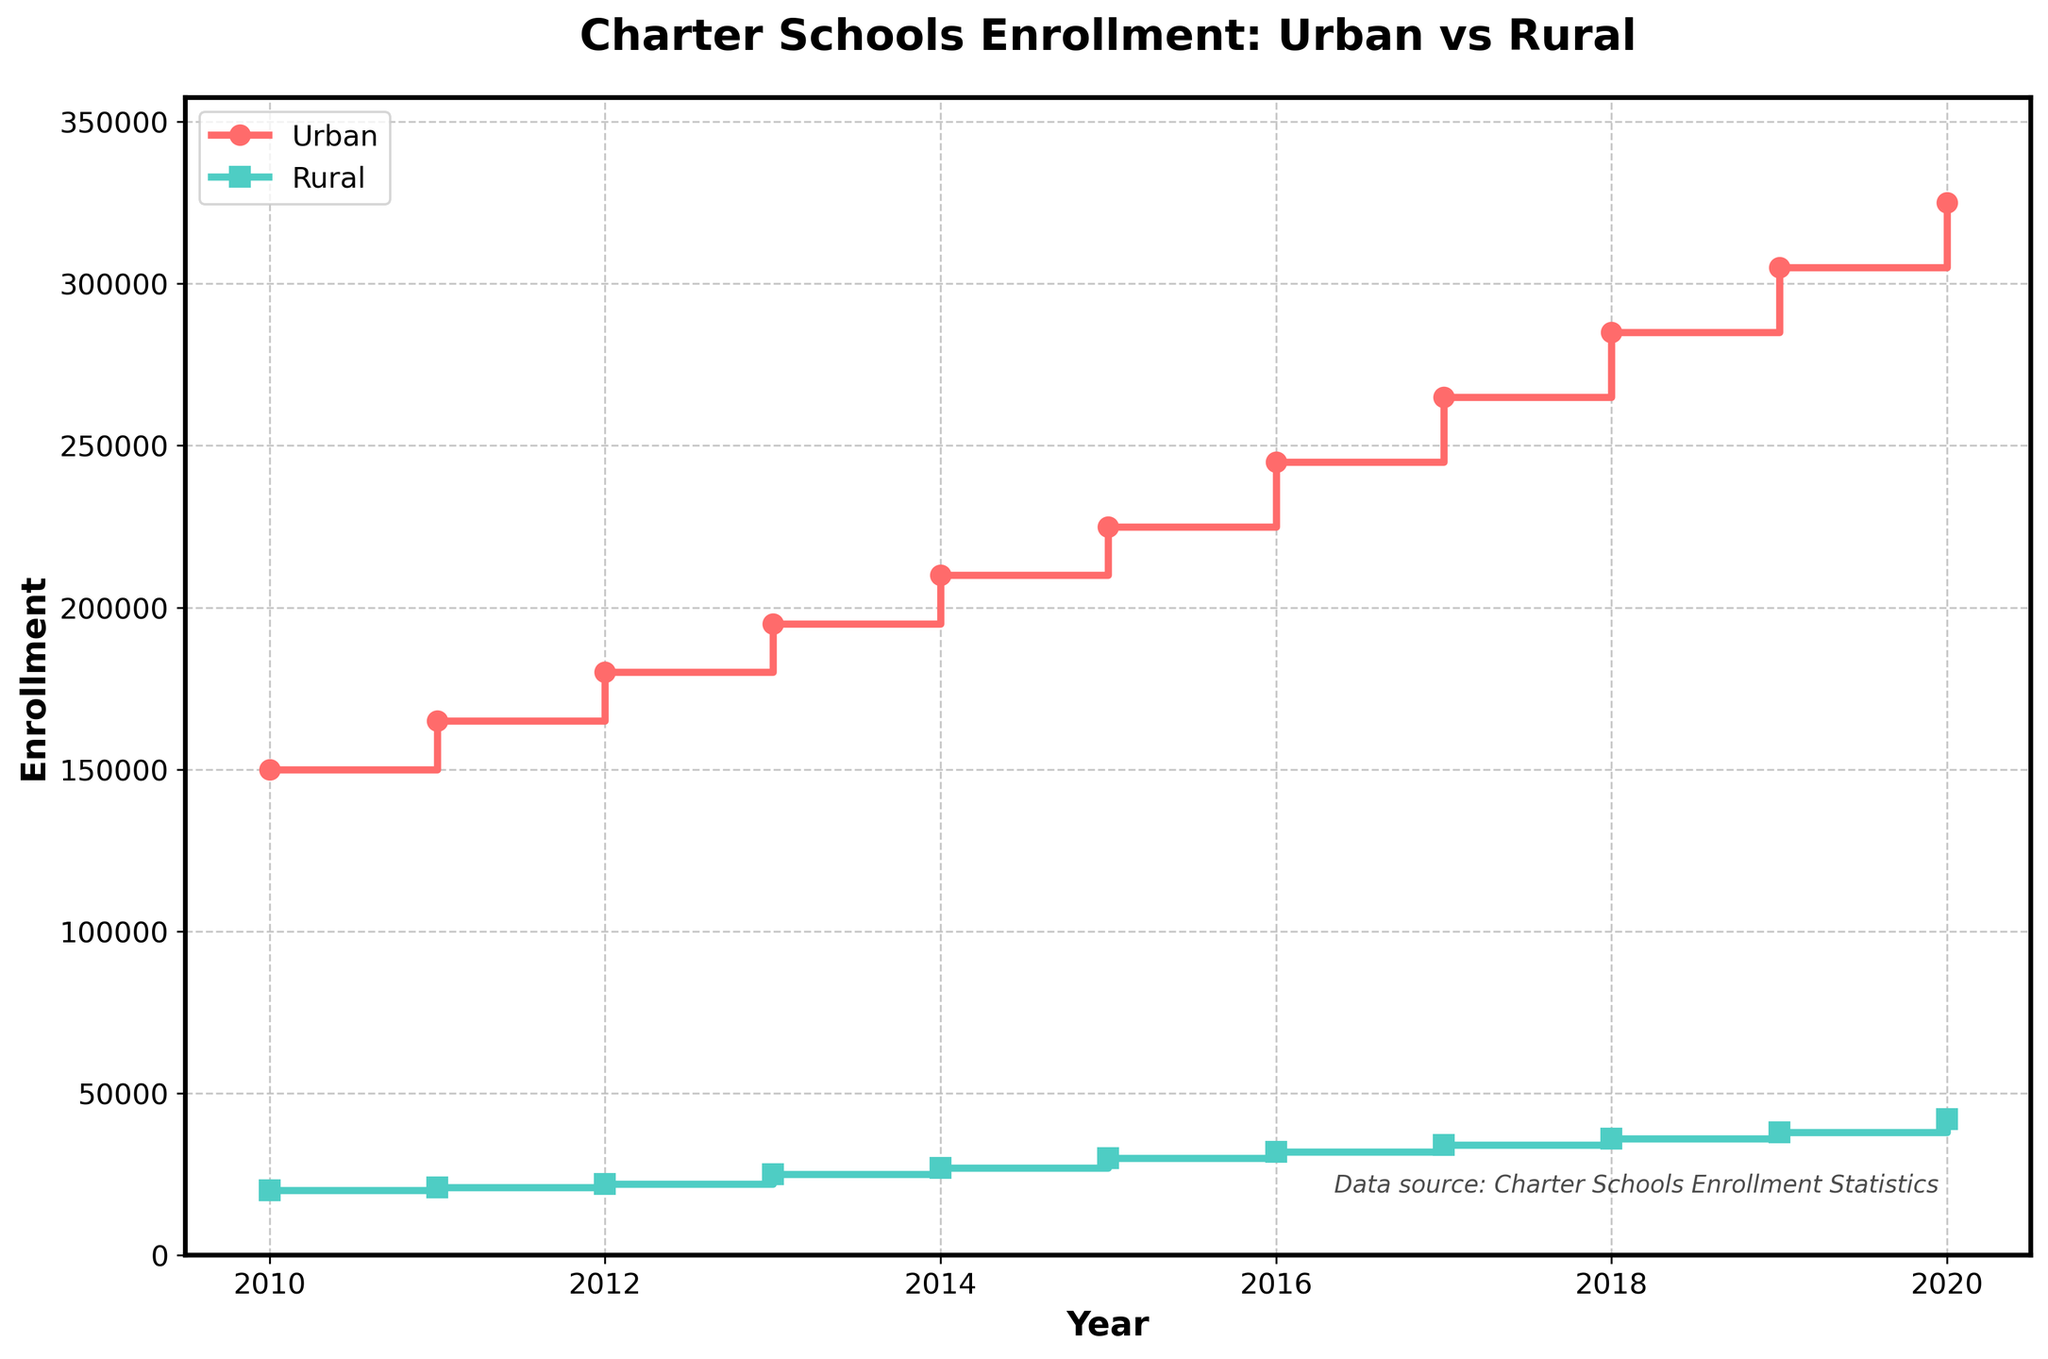What is the title of the plot? The title of the plot is typically found at the top and is designed to provide a concise summary of what the chart is displaying. From the provided details, the title is "Charter Schools Enrollment: Urban vs Rural".
Answer: Charter Schools Enrollment: Urban vs Rural What are the colors used to distinguish between urban and rural data? The plot uses different colors for different categories to make it easy to distinguish between them. According to the description, urban data is marked in a shade of red and rural data in a shade of green.
Answer: Red and green What is the difference in enrollment between urban and rural charter schools in 2015? Locate the values for the year 2015. For urban, it's 225,000, and for rural, it's 30,000. Subtract the rural value from the urban value (225,000 - 30,000).
Answer: 195,000 By how much did rural charter school enrollment increase from 2010 to 2020? Find the enrollment figures for rural areas in 2010 (20,000) and 2020 (42,000). Calculate the difference by subtracting the 2010 figure from the 2020 figure (42,000 - 20,000).
Answer: 22,000 Which year saw the largest increase in urban charter school enrollment? Examine the increases from year to year for urban enrollments and identify the largest jump. For instance, check the differences: 165,000 - 150,000 = 15,000; 180,000 - 165,000 = 15,000, etc.
Answer: Not explicitly clear from provided data How does the enrollment growth trend in urban areas compare to that in rural areas over the decade? Graphically, one can compare the steepness and general direction of the lines for urban and rural enrollments. Urban growth appears steeper and consistently upward compared to the more gradual rural growth.
Answer: Urban growth is steeper and more consistent At what points do both urban and rural enrollments show the same pattern of growth? Identifying patterns involves looking for parallel movements or similar stepwise increases across the years for both data sets in the chart.
Answer: Both show consistent growth, but no exact points of same pattern How did rural charter school enrollment change from 2013 to 2016? Check the enrollment figures for rural charter schools in 2013 (25,000) and 2016 (32,000). Calculate the difference by subtracting 25,000 from 32,000.
Answer: Increased by 7,000 What is the average enrollment in rural charter schools from 2010 to 2020? Average can be found by summing all the rural enrollments from 2010 to 2020 and then dividing by the number of years (11). Sum: 20,000 + 21,000 + 22,000 + 25,000 + 27,000 + 30,000 + 32,000 + 34,000 + 36,000 + 38,000 + 42,000 = 327,000. Average = 327,000 / 11.
Answer: 29,727 